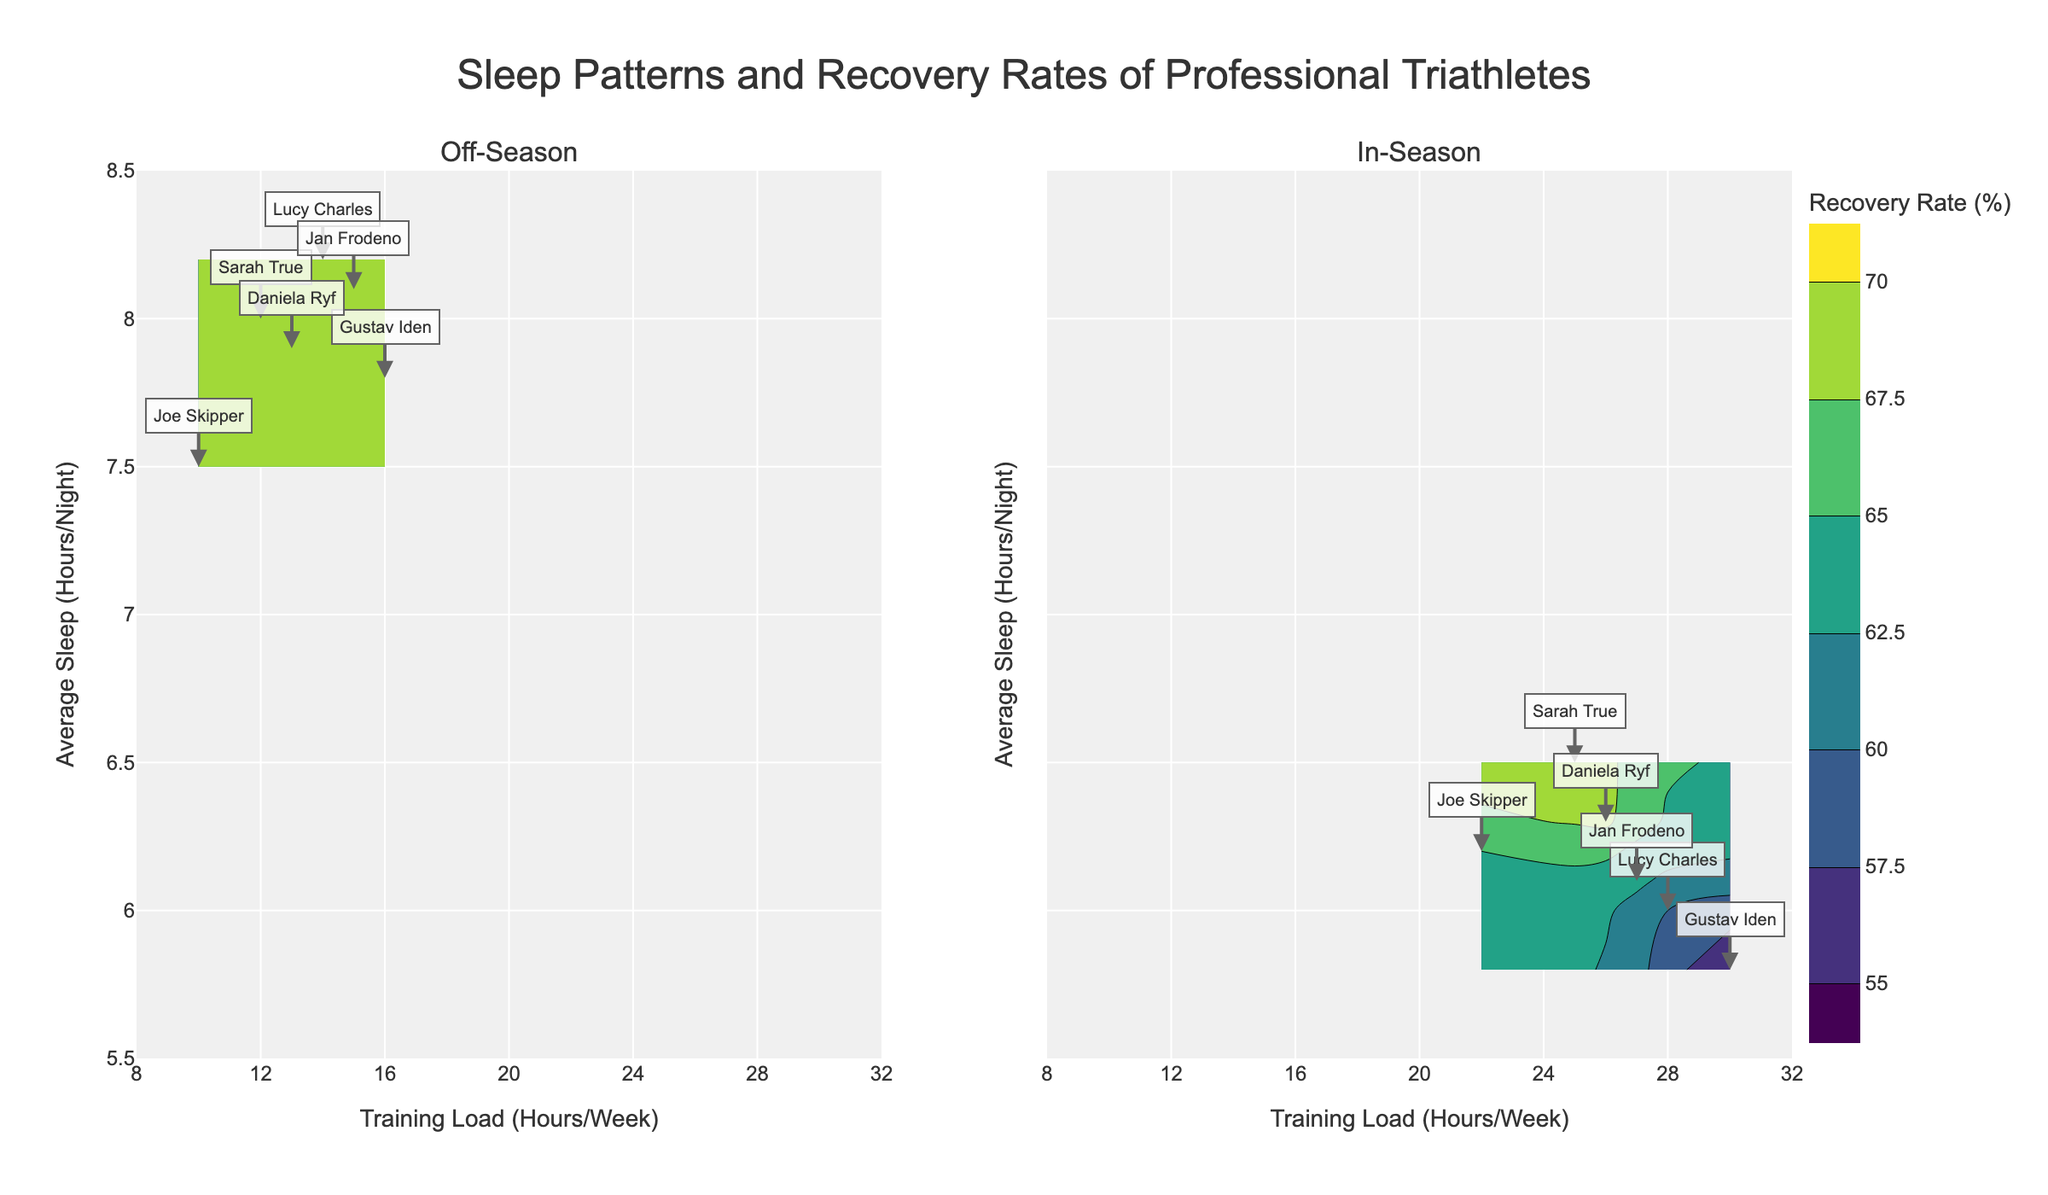what is the title of the figure? The title of the figure is written at the top and states "Sleep Patterns and Recovery Rates of Professional Triathletes"
Answer: Sleep Patterns and Recovery Rates of Professional Triathletes How does the training load of Sarah True differ between the off-season and the in-season? In the off-season subplot, Sarah True's training load is around 12 hours per week. In the in-season subplot, her training load is around 25 hours per week.
Answer: Off-season: 12 hours/week, In-season: 25 hours/week What is the range of recovery rates shown in the off-season subplot? To find the range of recovery rates, look at the contour lines in the off-season subplot. The contours are plotted between 60% and 90%.
Answer: 60% to 90% Which athlete has the highest recovery rate in the off-season? In the off-season subplot, checking each annotated athlete's recovery rate reveals that Lucy Charles has the highest recovery rate at 90%.
Answer: Lucy Charles Between off-season and in-season, which period shows a greater variability in recovery rates? To determine variability, compare the contour intervals. The off-season contours range from 60% to 90% with intervals of 5%, while the in-season ranges from 55% to 70% with intervals of 2.5%, indicating a greater variability in the off-season.
Answer: Off-season How does the average sleep time of Joe Skipper change from off-season to in-season? In the off-season, Joe Skipper’s average sleep is 7.5 hours/night. In the in-season, it decreases to 6.2 hours/night.
Answer: Off-season: 7.5 hours/night, In-season: 6.2 hours/night Which period shows a higher variation in the training load (in-season or off-season)? Looking at the x-axis of both subplots, the off-season training load ranges from 10 to 16 hours per week, while the in-season ranges from 22 to 30 hours per week, indicating a higher variation in the in-season period.
Answer: In-season What is the recovery rate of Jan Frodeno during the off-season? Locate Jan Frodeno in the off-season subplot; his recovery rate is around 89%.
Answer: 89% Who has the lowest recovery rate during the in-season, and what is that rate? In the in-season subplot, Gustav Iden has the lowest recovery rate of 55%.
Answer: Gustav Iden, 55% Compare the sleep patterns of athletes in the off-season with those in the in-season. What difference do you notice? In the off-season subplot, athletes have average sleep times ranging from 7.5 to 8.2 hours per night. In the in-season subplot, average sleep times decrease, ranging from 5.8 to 6.5 hours per night.
Answer: More sleep in the off-season 